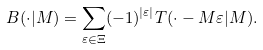Convert formula to latex. <formula><loc_0><loc_0><loc_500><loc_500>B ( \cdot | M ) = \sum _ { \varepsilon \in \Xi } ( - 1 ) ^ { | \varepsilon | } T ( \cdot - M \varepsilon | M ) .</formula> 